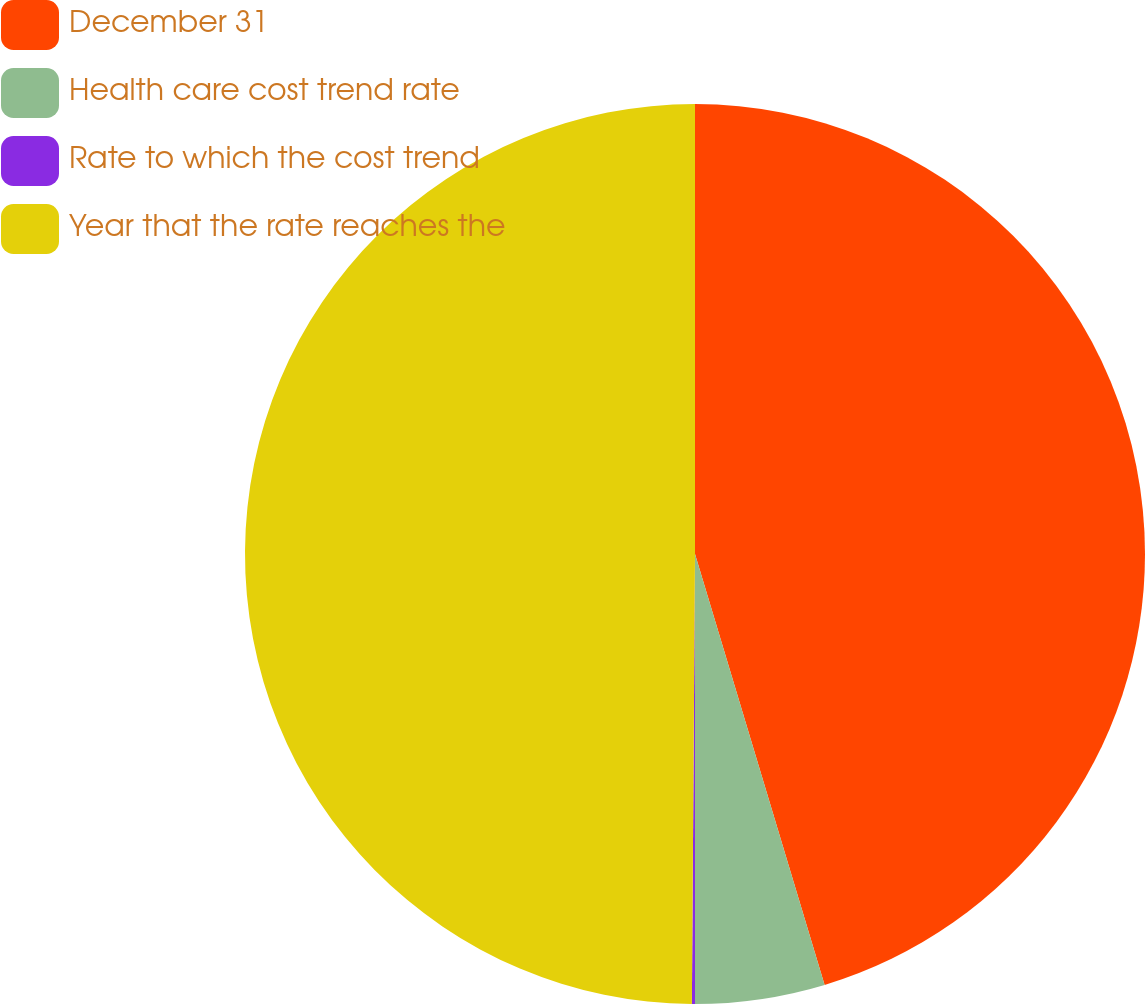Convert chart. <chart><loc_0><loc_0><loc_500><loc_500><pie_chart><fcel>December 31<fcel>Health care cost trend rate<fcel>Rate to which the cost trend<fcel>Year that the rate reaches the<nl><fcel>45.35%<fcel>4.65%<fcel>0.11%<fcel>49.89%<nl></chart> 